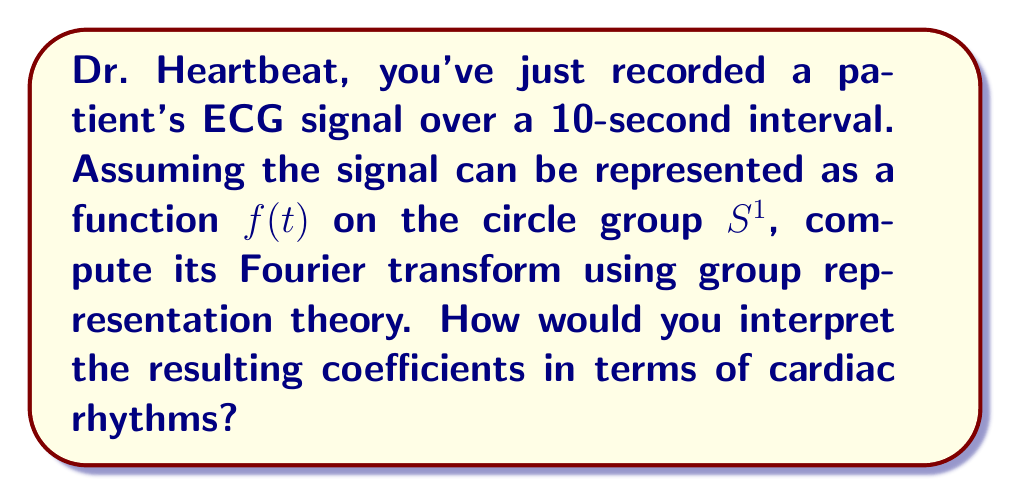Could you help me with this problem? Let's approach this step-by-step:

1) The circle group $S^1$ can be identified with the interval $[0, 10]$ with endpoints identified, as our signal is periodic over 10 seconds.

2) The irreducible representations of $S^1$ are given by the characters $\chi_n(t) = e^{2\pi int/10}$ for $n \in \mathbb{Z}$.

3) The Fourier transform in the context of group representation theory is given by:

   $$\hat{f}(n) = \int_0^{10} f(t) \overline{\chi_n(t)} dt = \int_0^{10} f(t) e^{-2\pi int/10} dt$$

4) This integral computes the Fourier coefficients $\hat{f}(n)$ for each $n$.

5) To compute this practically:
   a) Discretize the signal into samples $f(t_k)$ at times $t_k = k\Delta t$, where $\Delta t$ is the sampling interval.
   b) Approximate the integral using a sum:
      $$\hat{f}(n) \approx \sum_{k=0}^{N-1} f(t_k) e^{-2\pi ink/N} \Delta t$$
   where $N$ is the number of samples.

6) This is equivalent to the Discrete Fourier Transform (DFT) of the signal.

7) Interpretation of coefficients:
   - $\hat{f}(0)$ represents the DC component (average value) of the signal.
   - $\hat{f}(1)$ and $\hat{f}(-1)$ correspond to the fundamental frequency (1 cycle per 10 seconds, or 0.1 Hz).
   - Higher $n$ values correspond to higher frequency components.

8) In terms of cardiac rhythms:
   - The coefficient with the largest magnitude (excluding $\hat{f}(0)$) corresponds to the dominant frequency of the heartbeat.
   - If this occurs at $n = 6$, for example, it would indicate a heart rate of 36 bpm (6 cycles per 10 seconds).
   - Other significant coefficients may indicate arrhythmias or other cardiac anomalies.
Answer: $\hat{f}(n) = \int_0^{10} f(t) e^{-2\pi int/10} dt$; interpret $|\hat{f}(n)|$ for cardiac rhythms. 